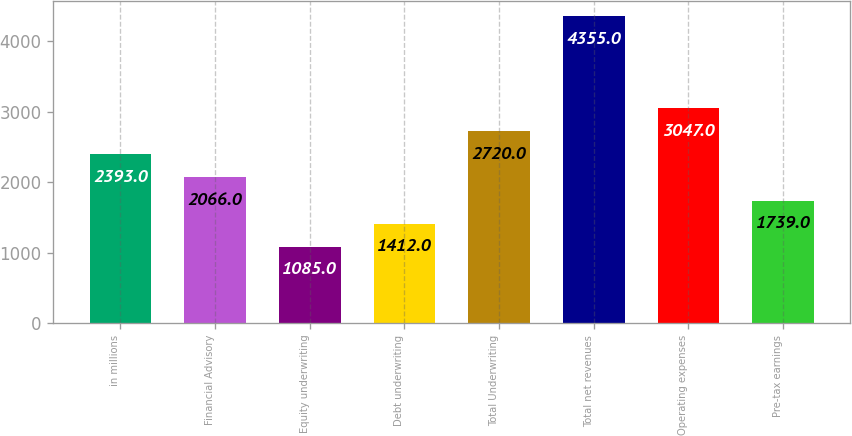Convert chart. <chart><loc_0><loc_0><loc_500><loc_500><bar_chart><fcel>in millions<fcel>Financial Advisory<fcel>Equity underwriting<fcel>Debt underwriting<fcel>Total Underwriting<fcel>Total net revenues<fcel>Operating expenses<fcel>Pre-tax earnings<nl><fcel>2393<fcel>2066<fcel>1085<fcel>1412<fcel>2720<fcel>4355<fcel>3047<fcel>1739<nl></chart> 